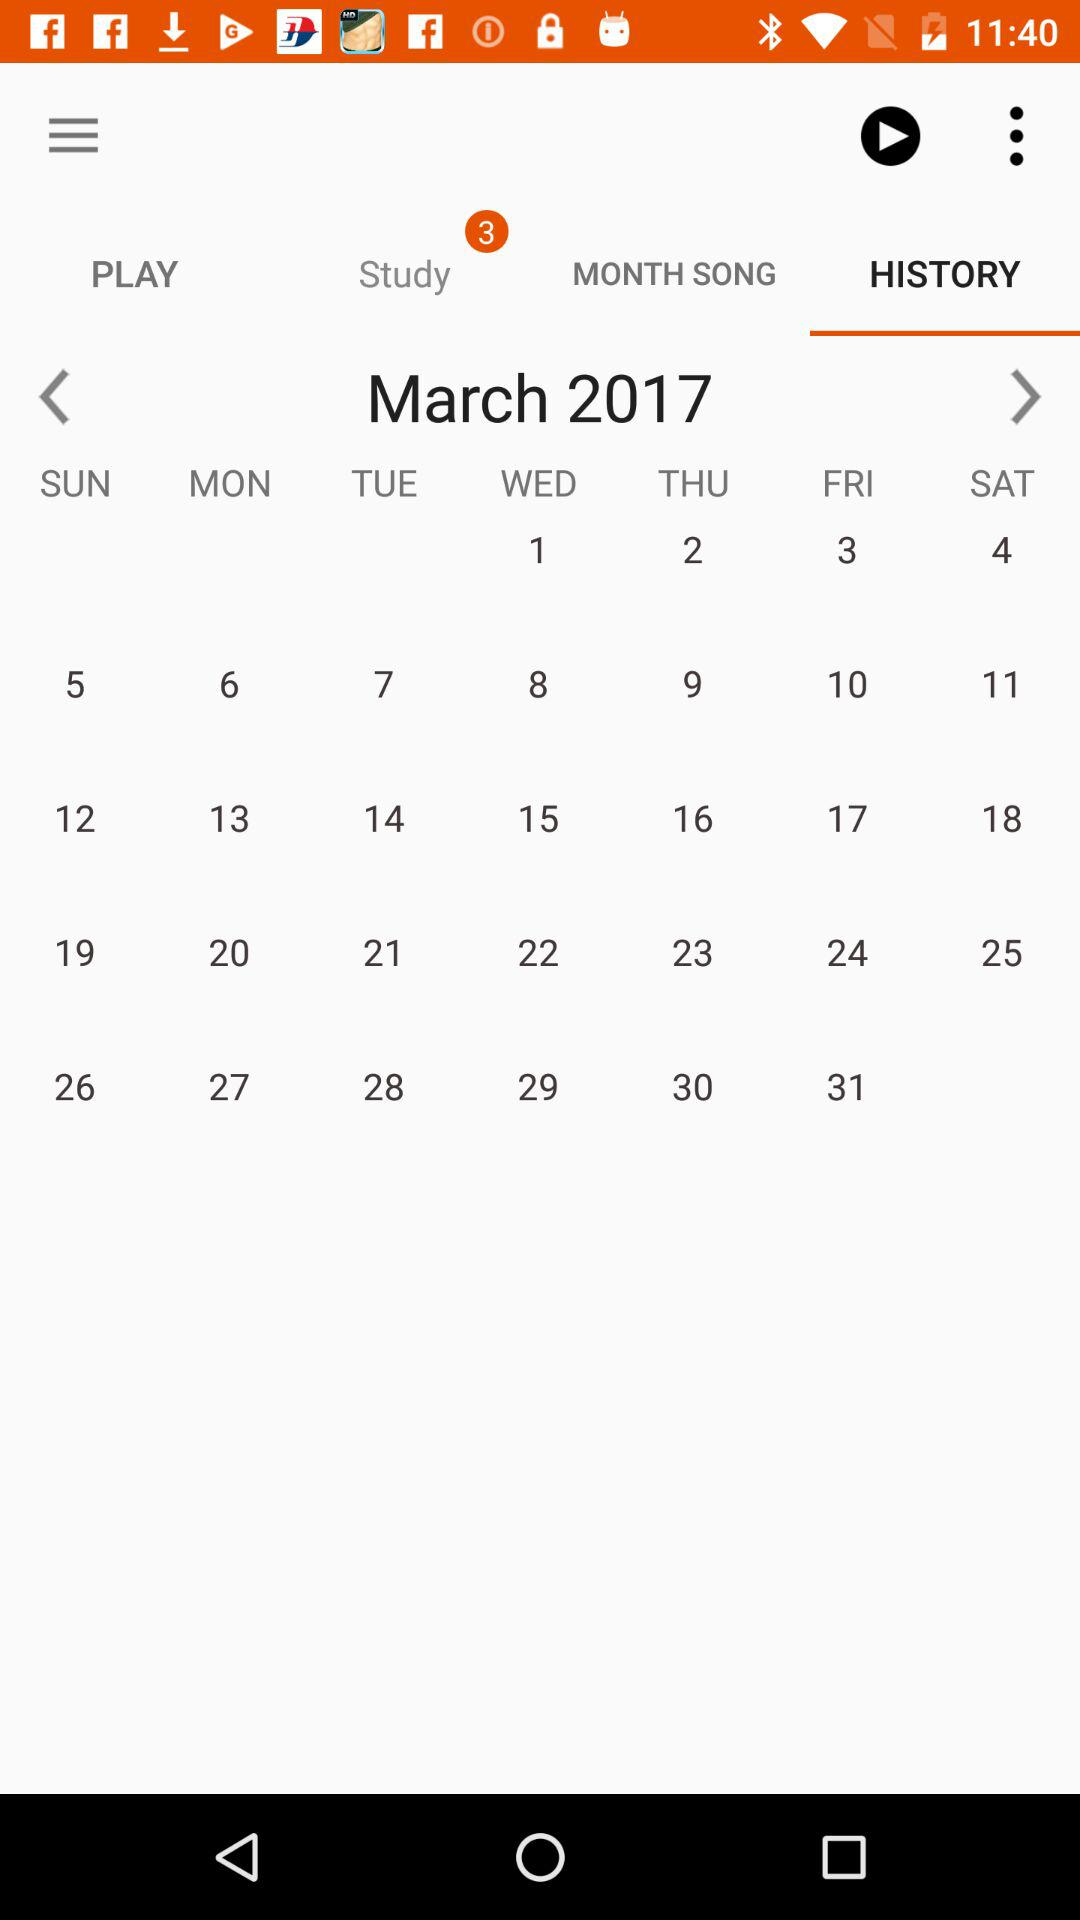What is the number of notifications for "Study"? The number of notifications for "Study" is 3. 